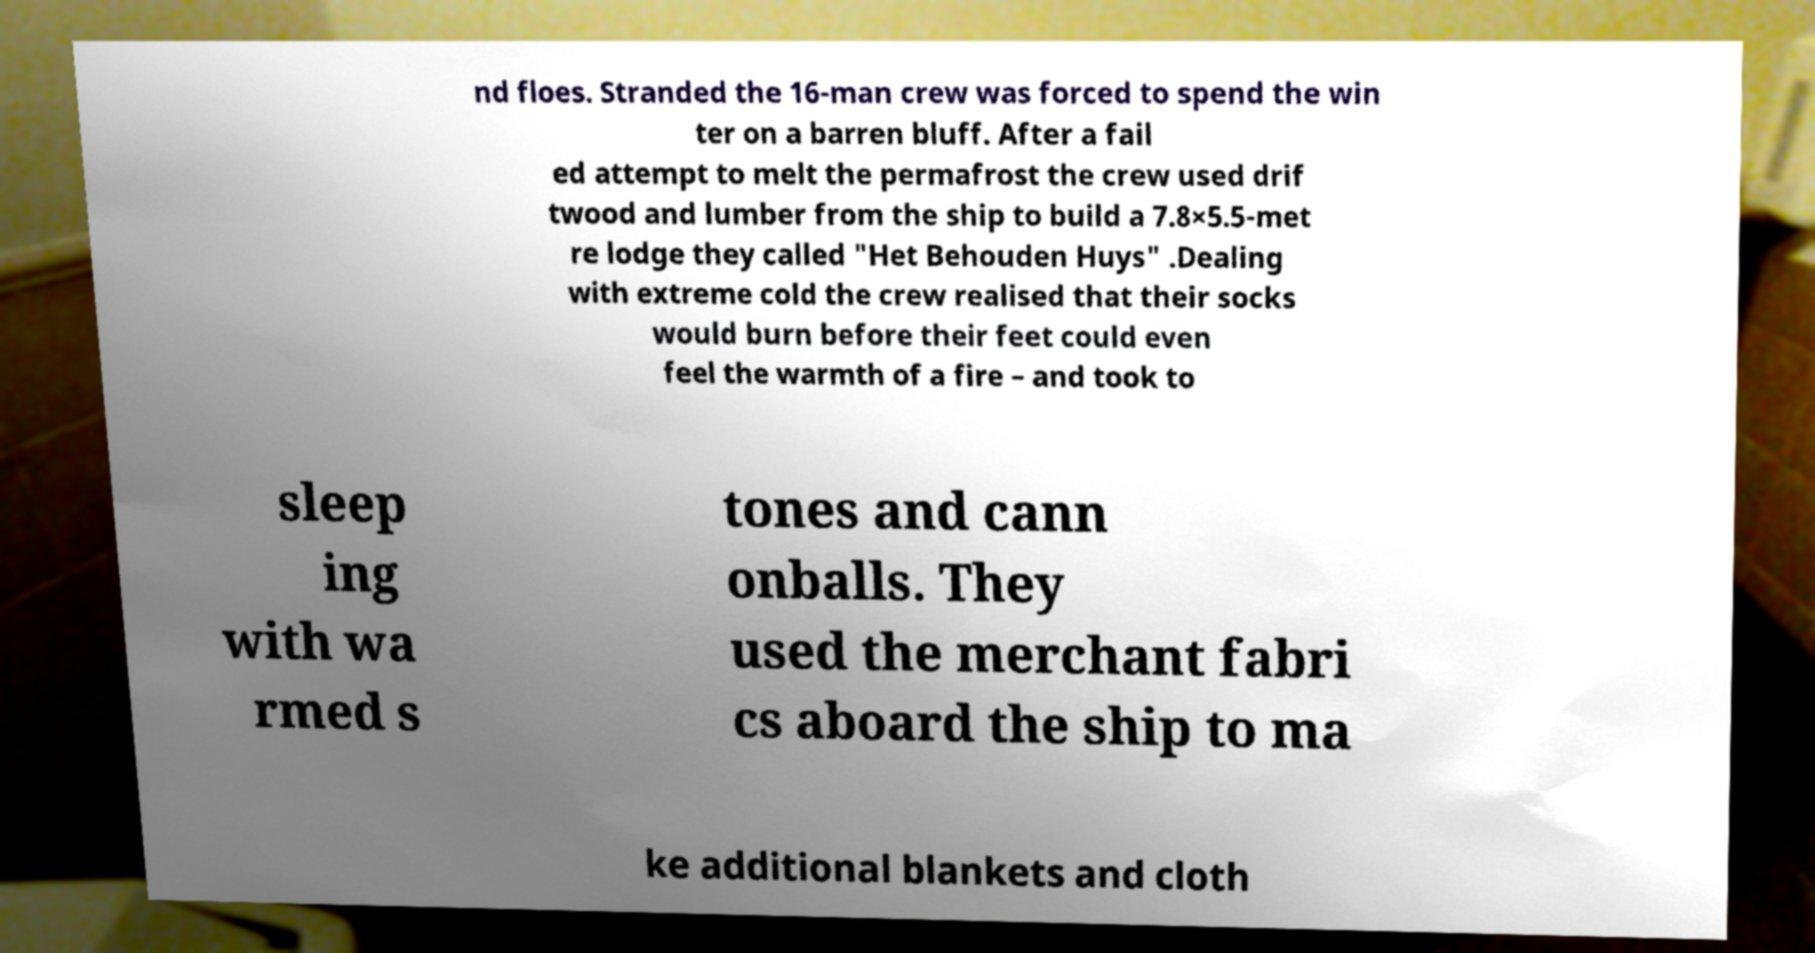Can you read and provide the text displayed in the image?This photo seems to have some interesting text. Can you extract and type it out for me? nd floes. Stranded the 16-man crew was forced to spend the win ter on a barren bluff. After a fail ed attempt to melt the permafrost the crew used drif twood and lumber from the ship to build a 7.8×5.5-met re lodge they called "Het Behouden Huys" .Dealing with extreme cold the crew realised that their socks would burn before their feet could even feel the warmth of a fire – and took to sleep ing with wa rmed s tones and cann onballs. They used the merchant fabri cs aboard the ship to ma ke additional blankets and cloth 